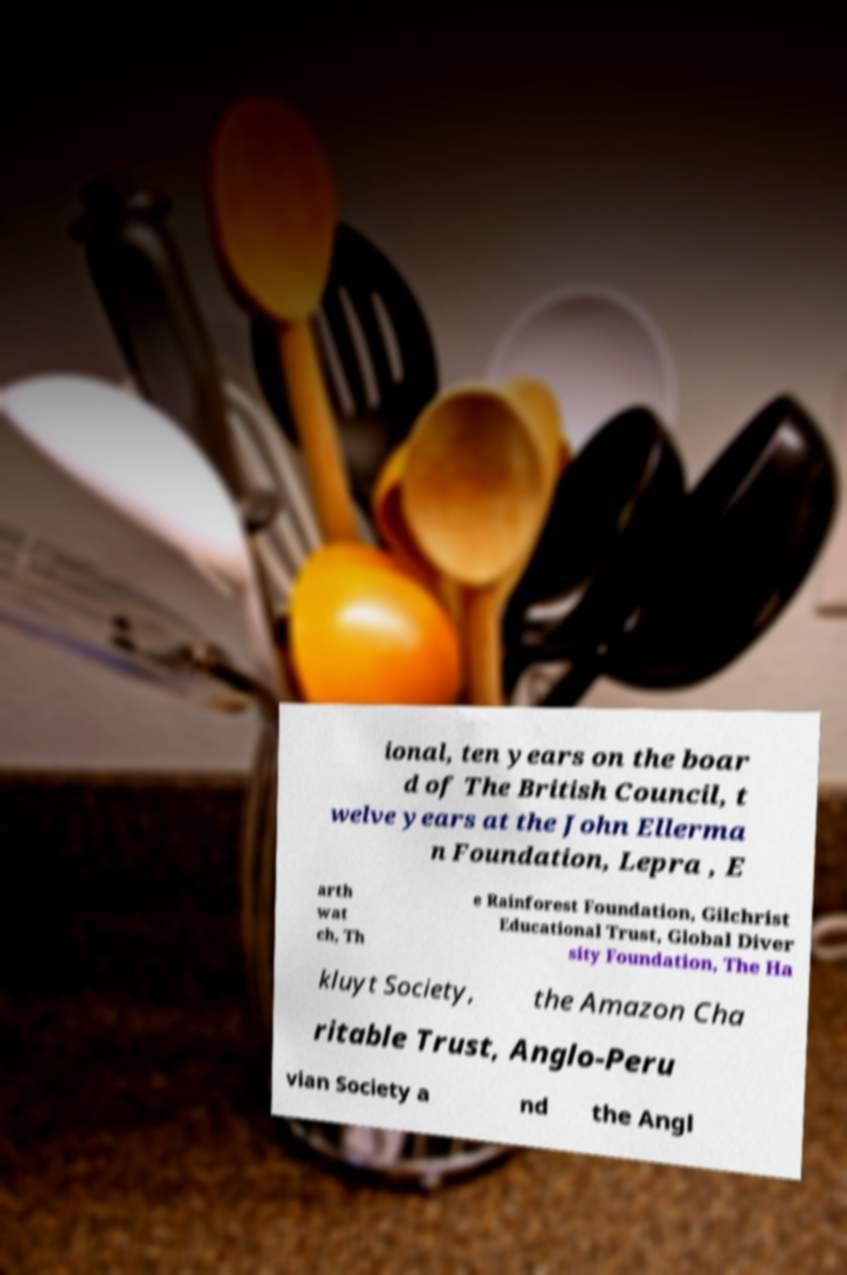For documentation purposes, I need the text within this image transcribed. Could you provide that? ional, ten years on the boar d of The British Council, t welve years at the John Ellerma n Foundation, Lepra , E arth wat ch, Th e Rainforest Foundation, Gilchrist Educational Trust, Global Diver sity Foundation, The Ha kluyt Society, the Amazon Cha ritable Trust, Anglo-Peru vian Society a nd the Angl 